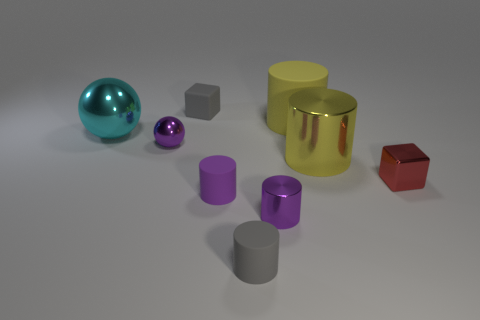Subtract all gray cylinders. How many cylinders are left? 4 Subtract all gray cylinders. How many cylinders are left? 4 Subtract all red cylinders. Subtract all purple balls. How many cylinders are left? 5 Subtract all cylinders. How many objects are left? 4 Add 1 purple rubber objects. How many purple rubber objects are left? 2 Add 2 big cyan cylinders. How many big cyan cylinders exist? 2 Subtract 1 gray blocks. How many objects are left? 8 Subtract all purple spheres. Subtract all shiny balls. How many objects are left? 6 